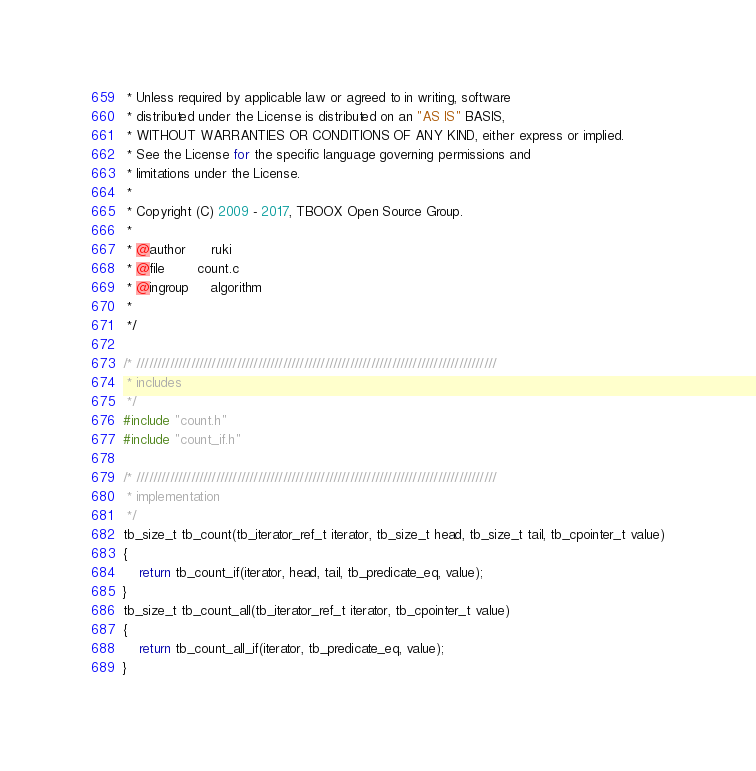Convert code to text. <code><loc_0><loc_0><loc_500><loc_500><_C_> * Unless required by applicable law or agreed to in writing, software
 * distributed under the License is distributed on an "AS IS" BASIS,
 * WITHOUT WARRANTIES OR CONDITIONS OF ANY KIND, either express or implied.
 * See the License for the specific language governing permissions and
 * limitations under the License.
 * 
 * Copyright (C) 2009 - 2017, TBOOX Open Source Group.
 *
 * @author      ruki
 * @file        count.c
 * @ingroup     algorithm
 *
 */

/* //////////////////////////////////////////////////////////////////////////////////////
 * includes
 */
#include "count.h"
#include "count_if.h"

/* //////////////////////////////////////////////////////////////////////////////////////
 * implementation
 */
tb_size_t tb_count(tb_iterator_ref_t iterator, tb_size_t head, tb_size_t tail, tb_cpointer_t value)
{
    return tb_count_if(iterator, head, tail, tb_predicate_eq, value);
} 
tb_size_t tb_count_all(tb_iterator_ref_t iterator, tb_cpointer_t value)
{
    return tb_count_all_if(iterator, tb_predicate_eq, value);
}

</code> 